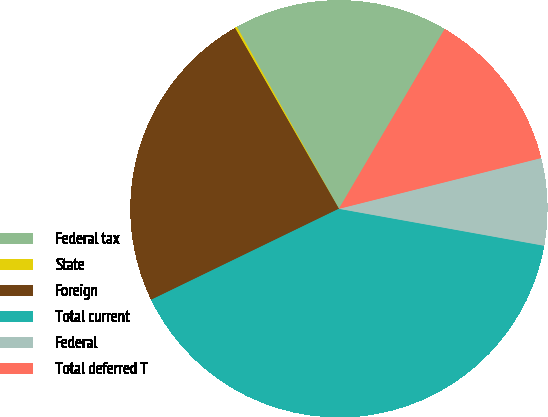Convert chart to OTSL. <chart><loc_0><loc_0><loc_500><loc_500><pie_chart><fcel>Federal tax<fcel>State<fcel>Foreign<fcel>Total current<fcel>Federal<fcel>Total deferred T<nl><fcel>16.6%<fcel>0.17%<fcel>23.88%<fcel>39.98%<fcel>6.75%<fcel>12.62%<nl></chart> 